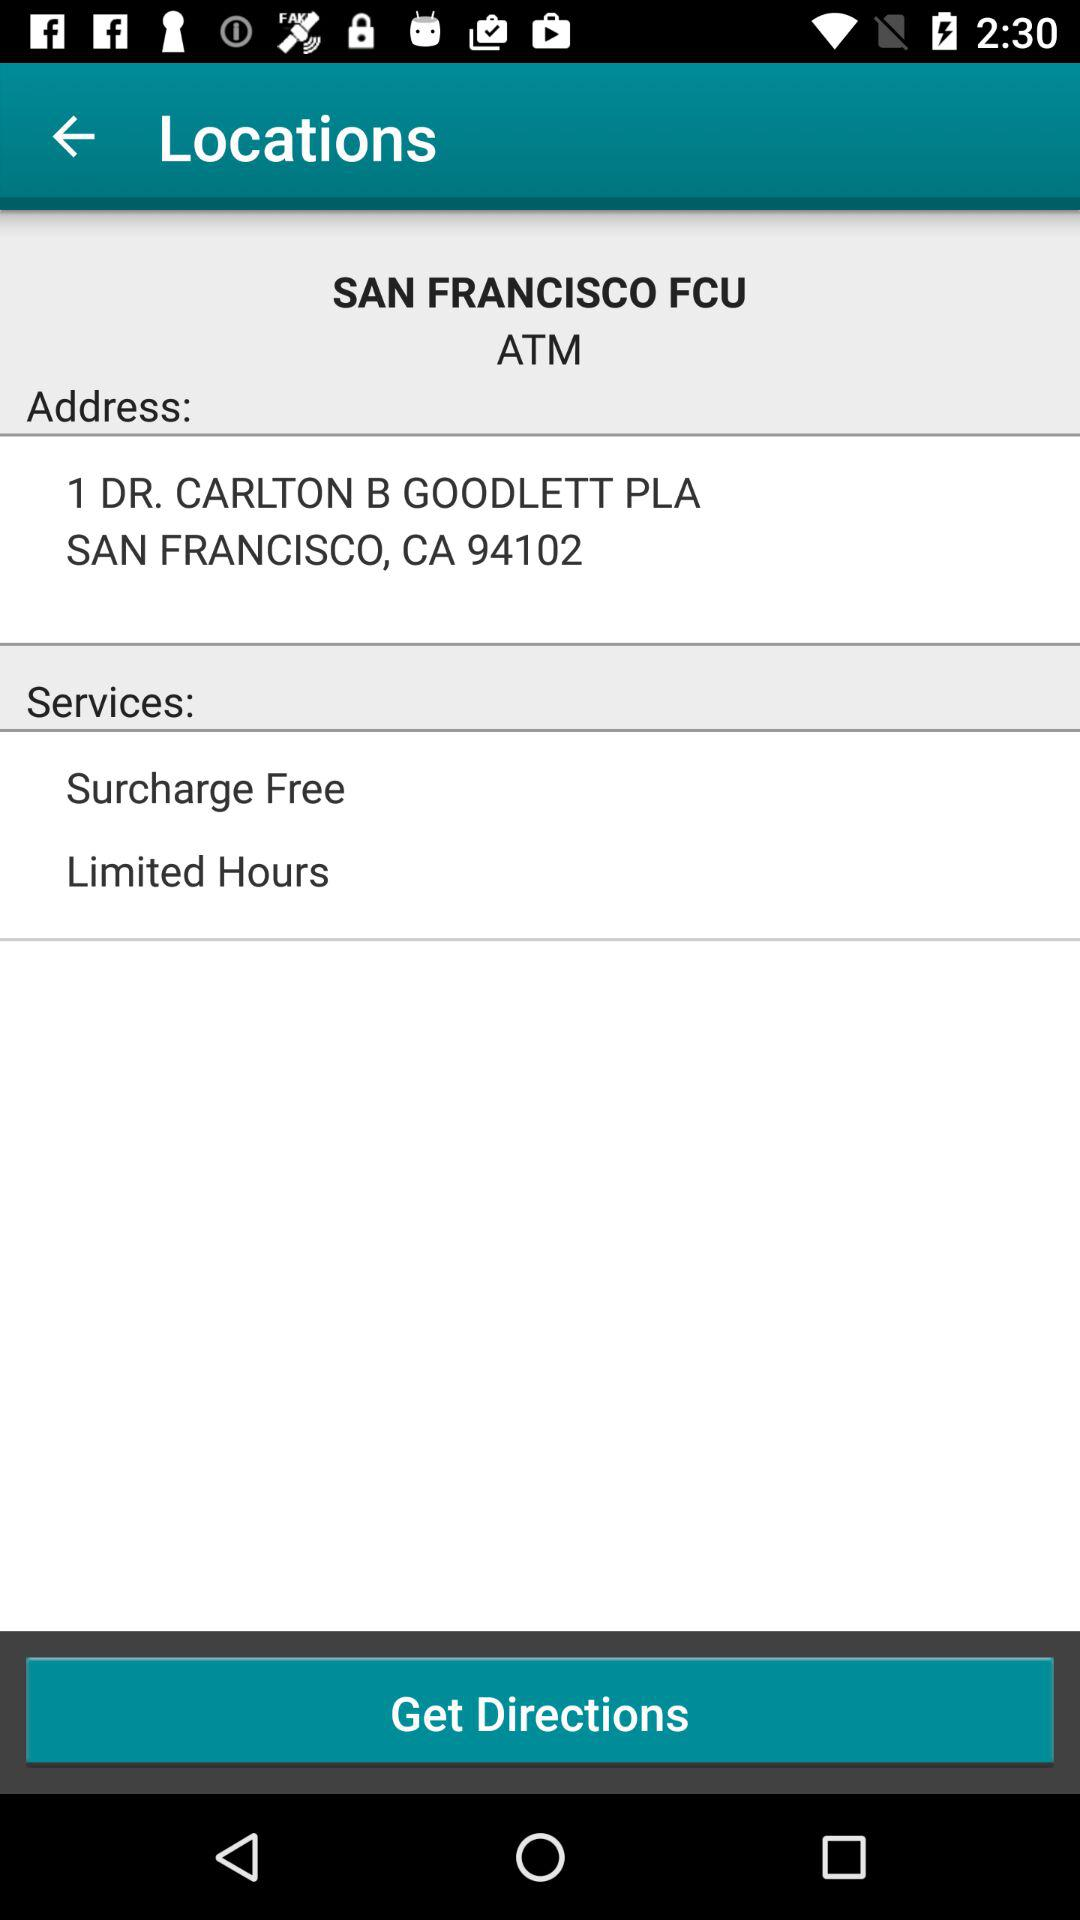What is the pincode of the location? The pincode of the location is 94102. 